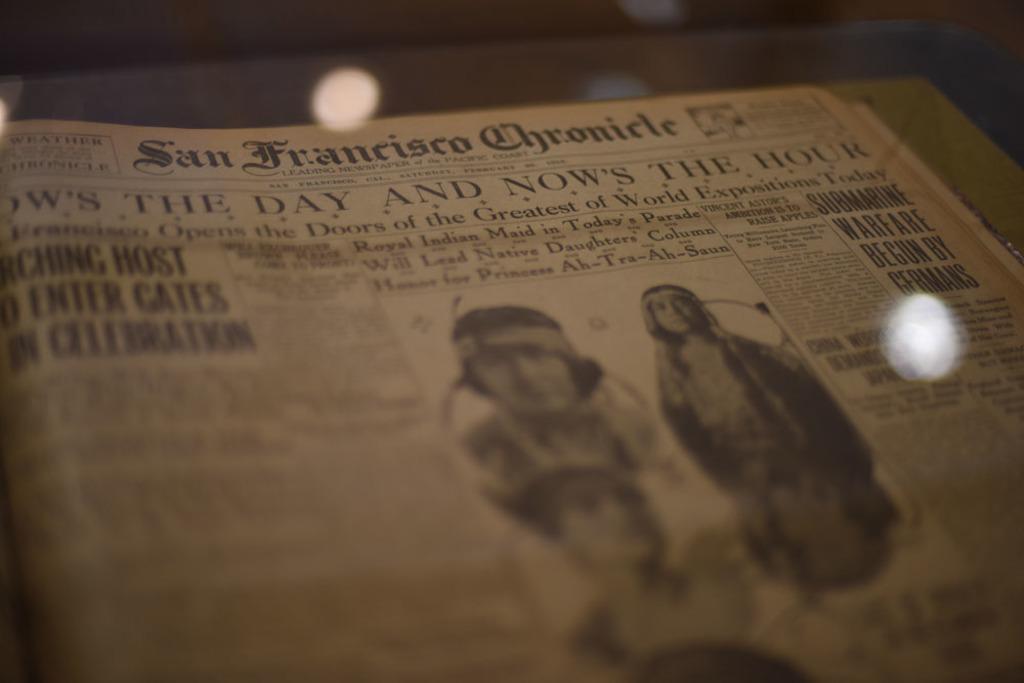Could you give a brief overview of what you see in this image? In the image I can see a newspaper in which I can see something is written and picture of few persons. I can see the black colored blurry background. 